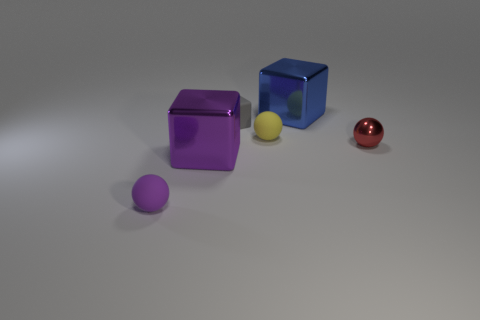What is the color distribution among the objects? There are two purple objects, one blue, one yellow, and one red object in the image. Which objects are the same shape? There are two cubes and two spheres. The cubes are purple and blue, while the spheres are purple and red. 